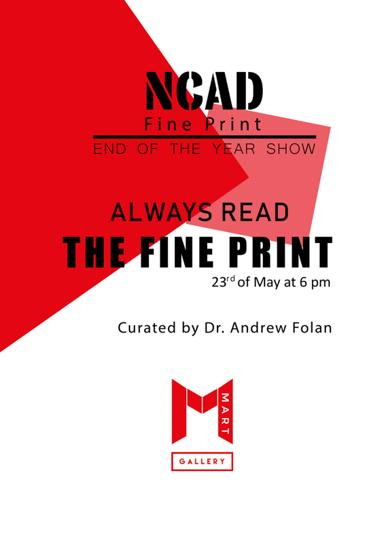When is the event taking place? The art show is scheduled for the 23rd of May at 6 pm, offering a perfect evening filled with artistic exploration. 